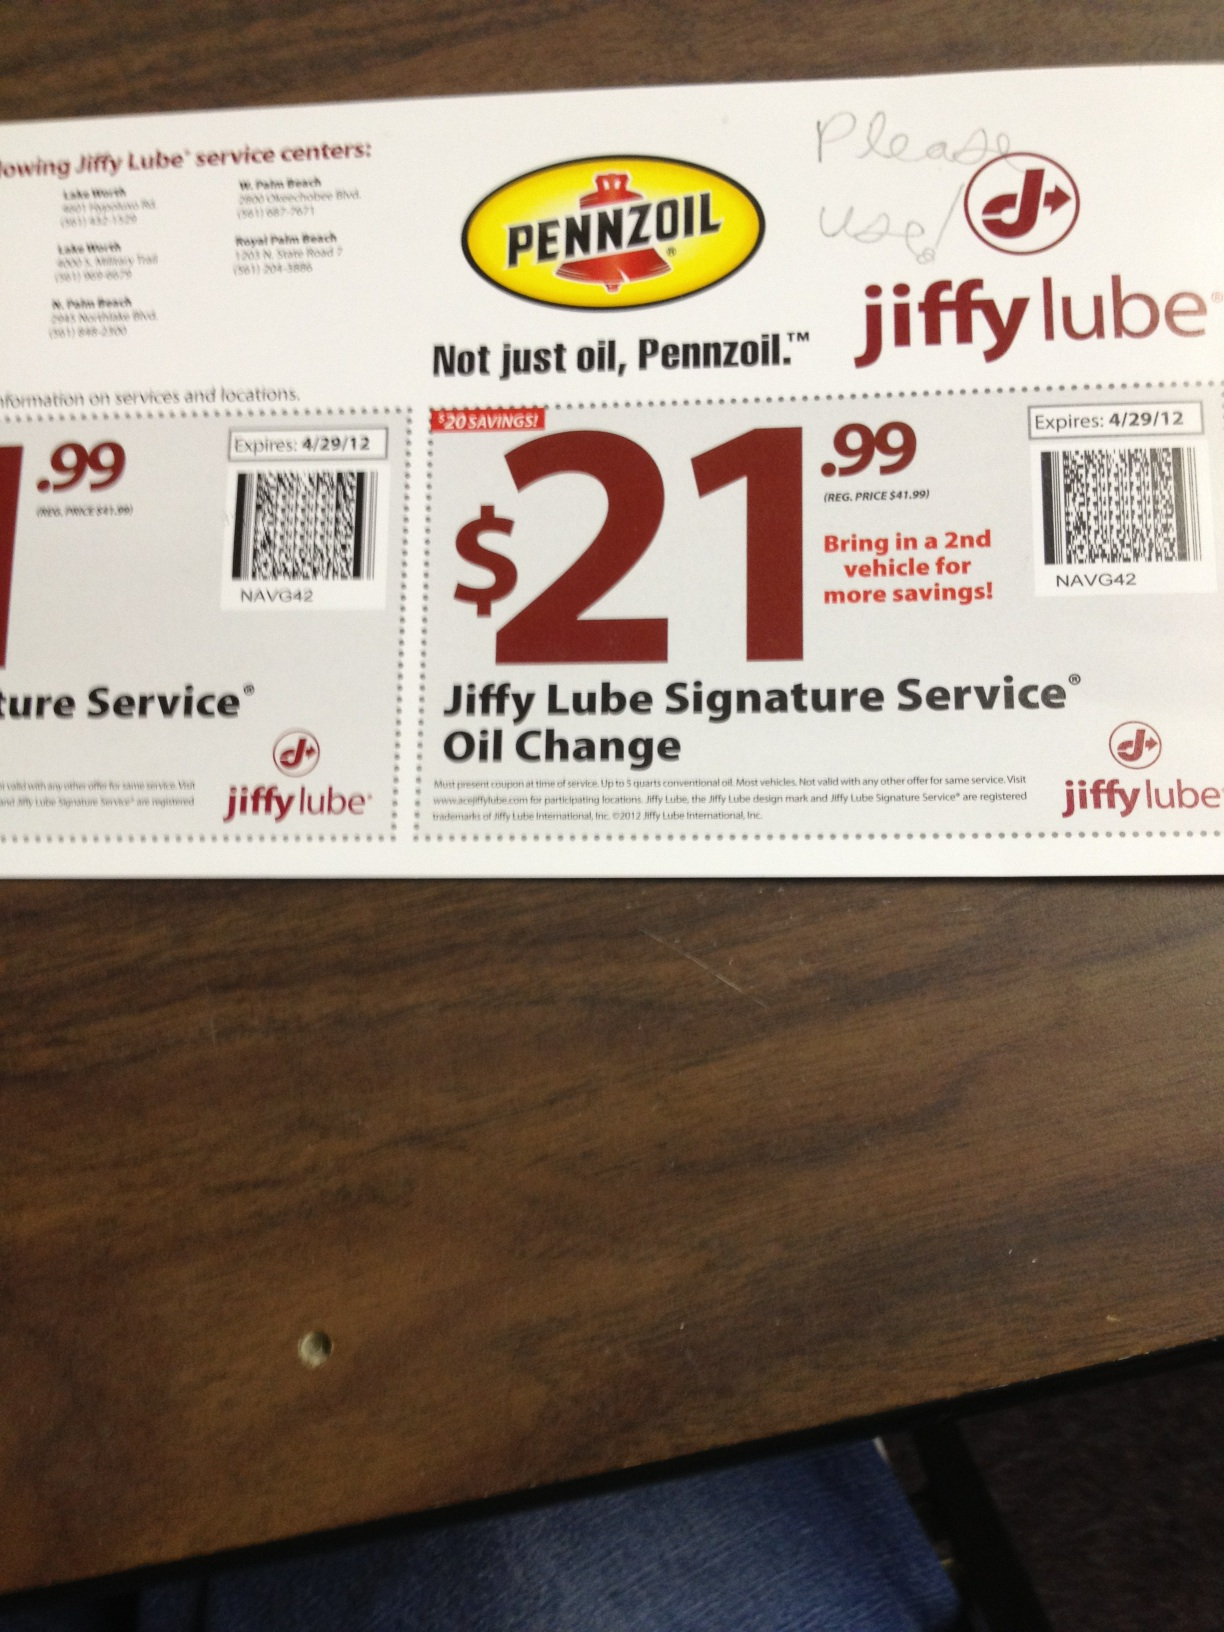Can this coupon be used for multiple vehicles? Yes, the coupon encourages bringing in a second vehicle for additional savings, though each vehicle may require a separate coupon. 